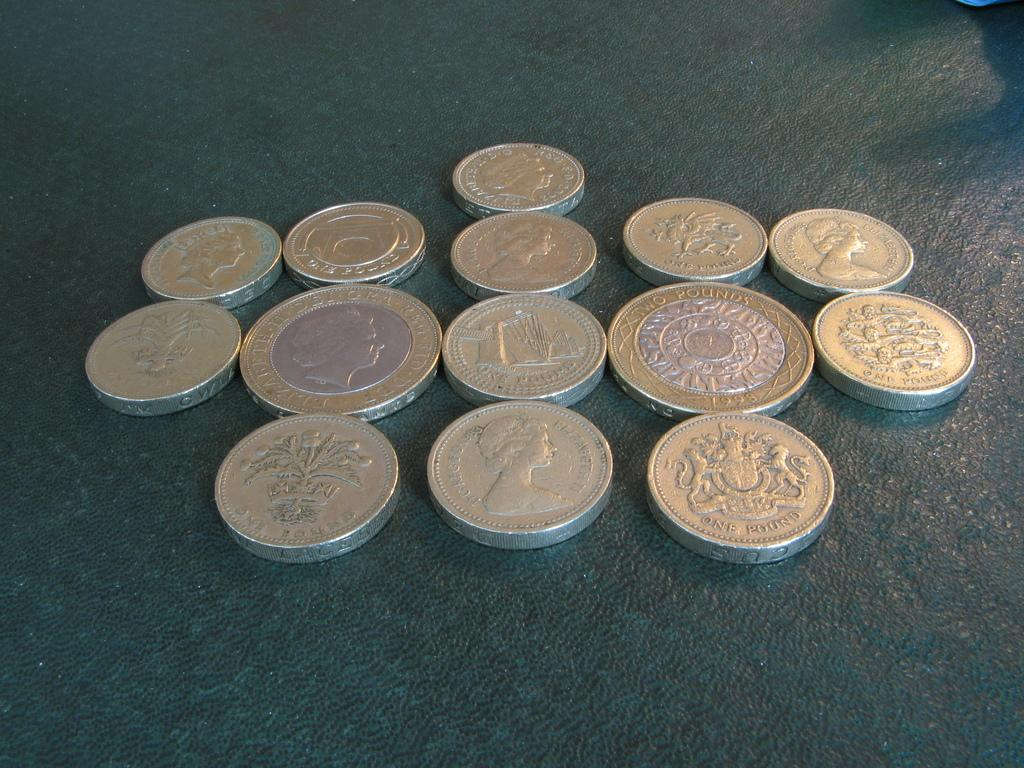<image>
Give a short and clear explanation of the subsequent image. Different pound coins are arranged in a symmetrical pattern. 